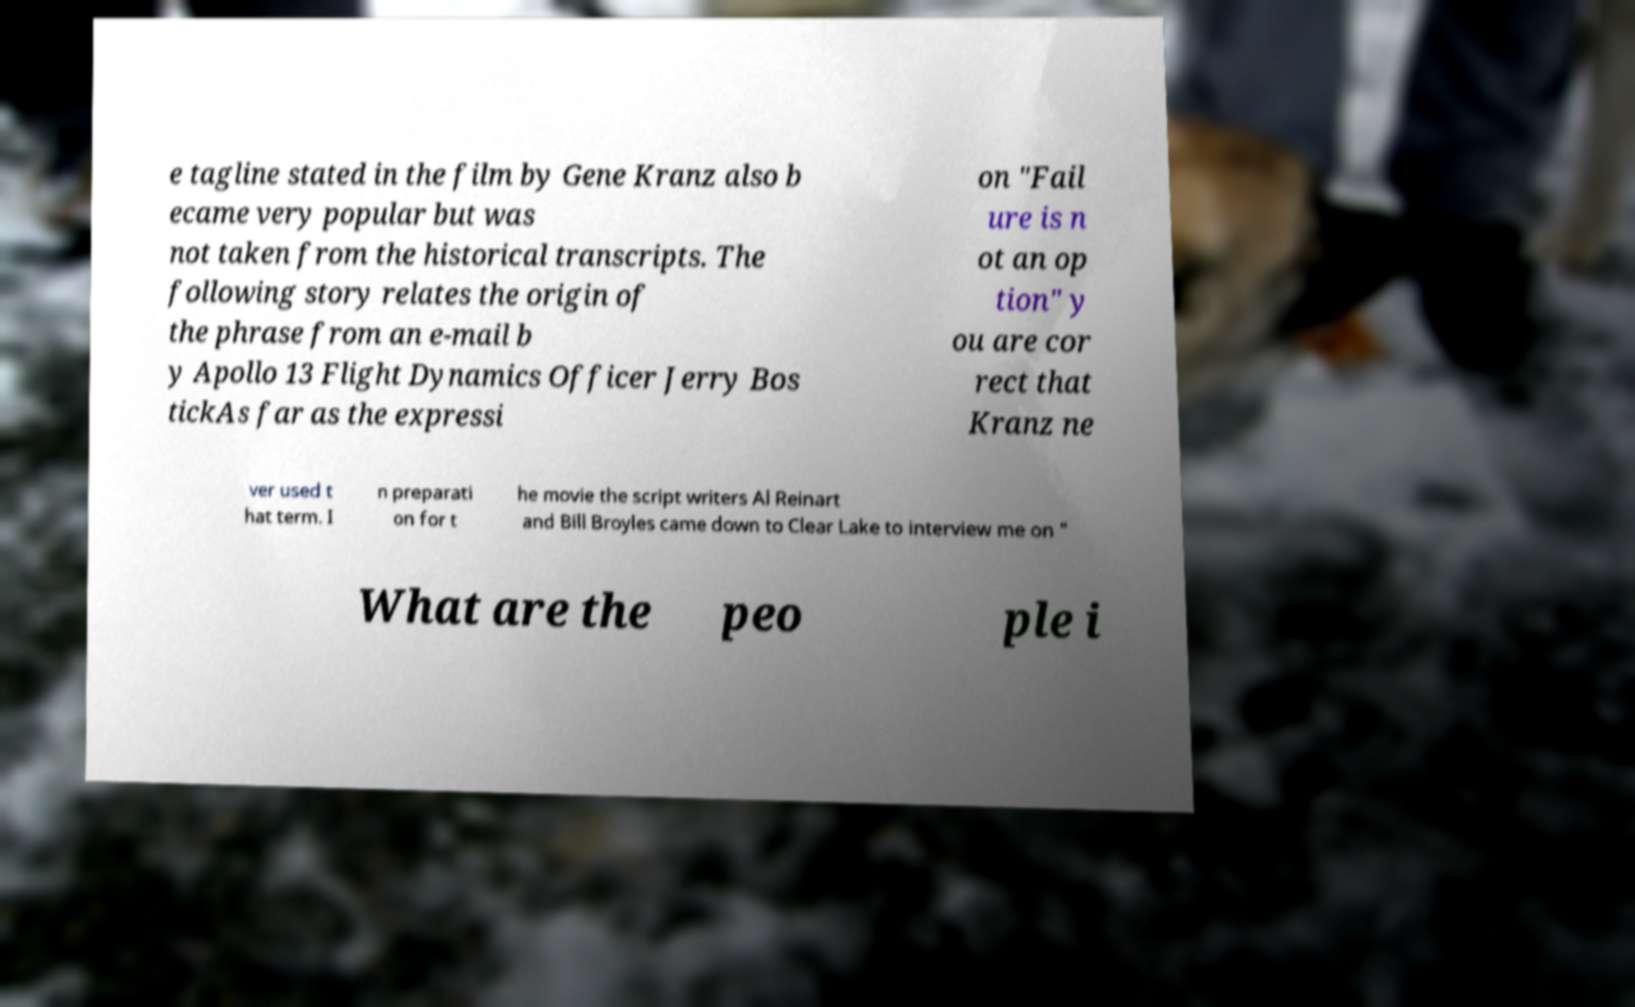What messages or text are displayed in this image? I need them in a readable, typed format. e tagline stated in the film by Gene Kranz also b ecame very popular but was not taken from the historical transcripts. The following story relates the origin of the phrase from an e-mail b y Apollo 13 Flight Dynamics Officer Jerry Bos tickAs far as the expressi on "Fail ure is n ot an op tion" y ou are cor rect that Kranz ne ver used t hat term. I n preparati on for t he movie the script writers Al Reinart and Bill Broyles came down to Clear Lake to interview me on " What are the peo ple i 